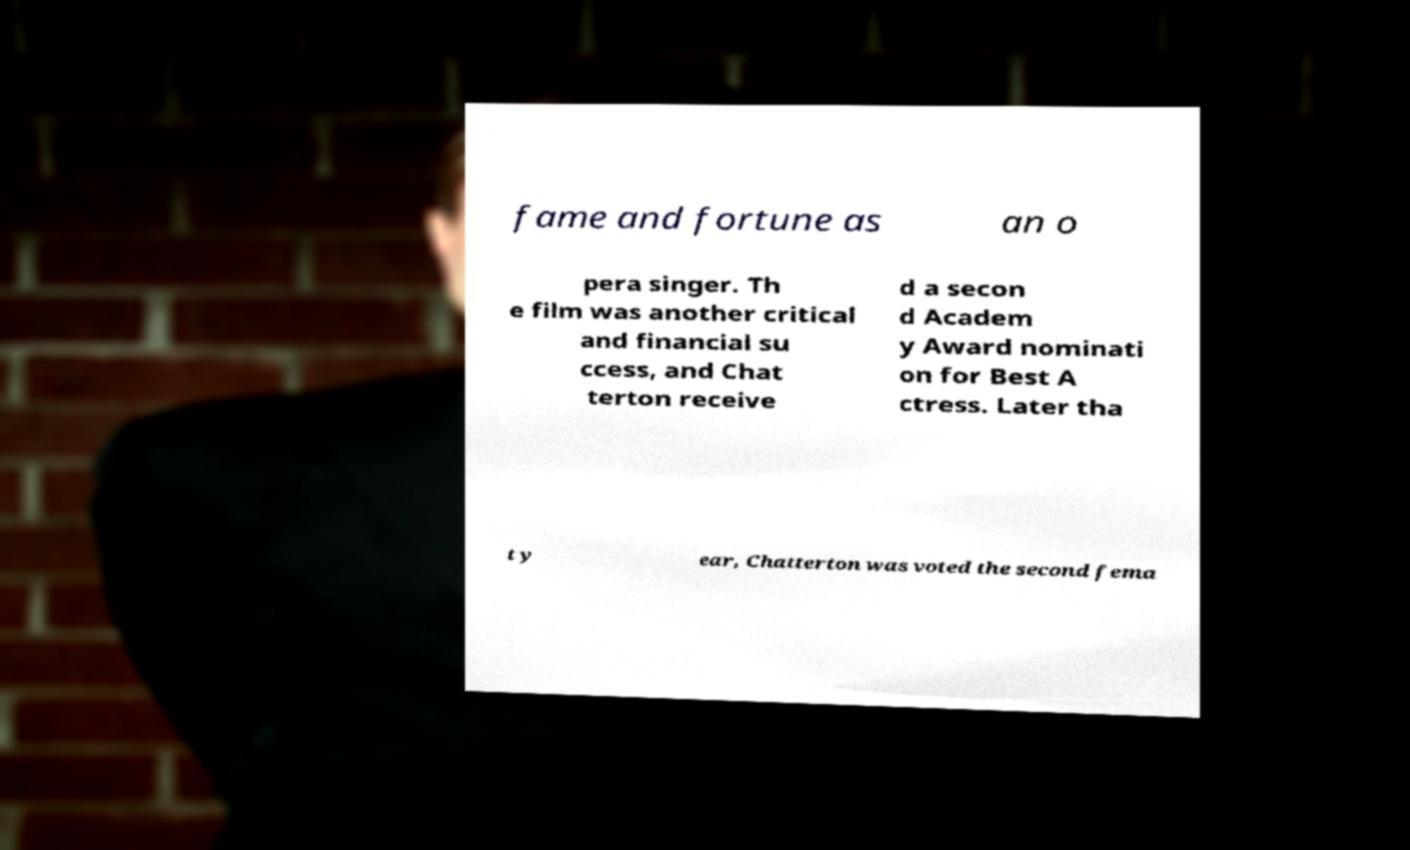There's text embedded in this image that I need extracted. Can you transcribe it verbatim? fame and fortune as an o pera singer. Th e film was another critical and financial su ccess, and Chat terton receive d a secon d Academ y Award nominati on for Best A ctress. Later tha t y ear, Chatterton was voted the second fema 